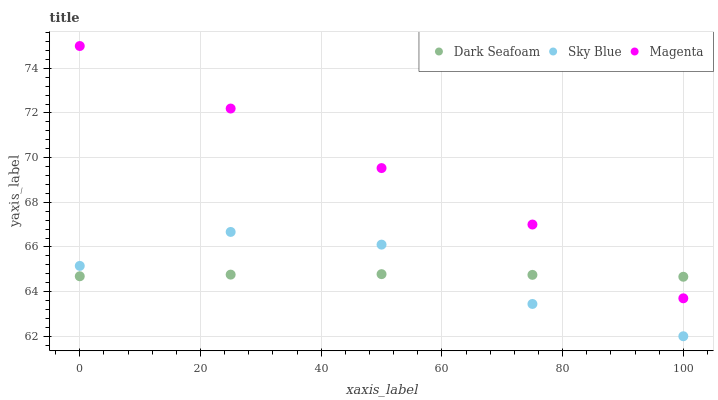Does Dark Seafoam have the minimum area under the curve?
Answer yes or no. Yes. Does Magenta have the maximum area under the curve?
Answer yes or no. Yes. Does Magenta have the minimum area under the curve?
Answer yes or no. No. Does Dark Seafoam have the maximum area under the curve?
Answer yes or no. No. Is Dark Seafoam the smoothest?
Answer yes or no. Yes. Is Sky Blue the roughest?
Answer yes or no. Yes. Is Magenta the smoothest?
Answer yes or no. No. Is Magenta the roughest?
Answer yes or no. No. Does Sky Blue have the lowest value?
Answer yes or no. Yes. Does Magenta have the lowest value?
Answer yes or no. No. Does Magenta have the highest value?
Answer yes or no. Yes. Does Dark Seafoam have the highest value?
Answer yes or no. No. Is Sky Blue less than Magenta?
Answer yes or no. Yes. Is Magenta greater than Sky Blue?
Answer yes or no. Yes. Does Sky Blue intersect Dark Seafoam?
Answer yes or no. Yes. Is Sky Blue less than Dark Seafoam?
Answer yes or no. No. Is Sky Blue greater than Dark Seafoam?
Answer yes or no. No. Does Sky Blue intersect Magenta?
Answer yes or no. No. 